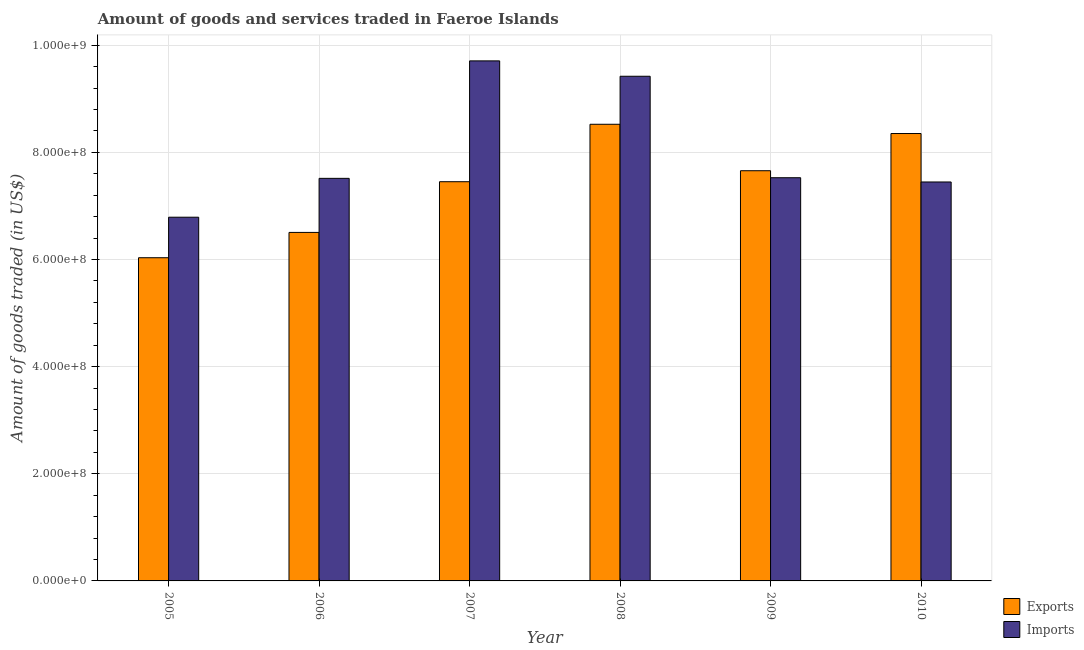How many groups of bars are there?
Your response must be concise. 6. Are the number of bars on each tick of the X-axis equal?
Provide a short and direct response. Yes. How many bars are there on the 2nd tick from the left?
Your answer should be very brief. 2. What is the label of the 1st group of bars from the left?
Ensure brevity in your answer.  2005. What is the amount of goods exported in 2007?
Ensure brevity in your answer.  7.45e+08. Across all years, what is the maximum amount of goods imported?
Provide a short and direct response. 9.71e+08. Across all years, what is the minimum amount of goods exported?
Offer a terse response. 6.03e+08. What is the total amount of goods exported in the graph?
Your answer should be very brief. 4.45e+09. What is the difference between the amount of goods exported in 2006 and that in 2010?
Make the answer very short. -1.85e+08. What is the difference between the amount of goods imported in 2006 and the amount of goods exported in 2008?
Make the answer very short. -1.91e+08. What is the average amount of goods imported per year?
Your response must be concise. 8.07e+08. What is the ratio of the amount of goods imported in 2005 to that in 2010?
Make the answer very short. 0.91. Is the amount of goods imported in 2005 less than that in 2006?
Provide a succinct answer. Yes. What is the difference between the highest and the second highest amount of goods imported?
Ensure brevity in your answer.  2.87e+07. What is the difference between the highest and the lowest amount of goods imported?
Your response must be concise. 2.92e+08. What does the 1st bar from the left in 2005 represents?
Your answer should be very brief. Exports. What does the 2nd bar from the right in 2010 represents?
Provide a succinct answer. Exports. What is the difference between two consecutive major ticks on the Y-axis?
Keep it short and to the point. 2.00e+08. Are the values on the major ticks of Y-axis written in scientific E-notation?
Offer a very short reply. Yes. Does the graph contain any zero values?
Provide a short and direct response. No. Does the graph contain grids?
Offer a very short reply. Yes. How many legend labels are there?
Your answer should be compact. 2. How are the legend labels stacked?
Ensure brevity in your answer.  Vertical. What is the title of the graph?
Provide a succinct answer. Amount of goods and services traded in Faeroe Islands. What is the label or title of the X-axis?
Provide a succinct answer. Year. What is the label or title of the Y-axis?
Your answer should be compact. Amount of goods traded (in US$). What is the Amount of goods traded (in US$) of Exports in 2005?
Your response must be concise. 6.03e+08. What is the Amount of goods traded (in US$) in Imports in 2005?
Give a very brief answer. 6.79e+08. What is the Amount of goods traded (in US$) of Exports in 2006?
Provide a succinct answer. 6.51e+08. What is the Amount of goods traded (in US$) of Imports in 2006?
Give a very brief answer. 7.51e+08. What is the Amount of goods traded (in US$) of Exports in 2007?
Offer a terse response. 7.45e+08. What is the Amount of goods traded (in US$) of Imports in 2007?
Ensure brevity in your answer.  9.71e+08. What is the Amount of goods traded (in US$) of Exports in 2008?
Offer a terse response. 8.52e+08. What is the Amount of goods traded (in US$) of Imports in 2008?
Keep it short and to the point. 9.42e+08. What is the Amount of goods traded (in US$) in Exports in 2009?
Ensure brevity in your answer.  7.66e+08. What is the Amount of goods traded (in US$) of Imports in 2009?
Your answer should be compact. 7.53e+08. What is the Amount of goods traded (in US$) in Exports in 2010?
Your answer should be very brief. 8.35e+08. What is the Amount of goods traded (in US$) in Imports in 2010?
Provide a succinct answer. 7.45e+08. Across all years, what is the maximum Amount of goods traded (in US$) in Exports?
Ensure brevity in your answer.  8.52e+08. Across all years, what is the maximum Amount of goods traded (in US$) of Imports?
Ensure brevity in your answer.  9.71e+08. Across all years, what is the minimum Amount of goods traded (in US$) in Exports?
Keep it short and to the point. 6.03e+08. Across all years, what is the minimum Amount of goods traded (in US$) in Imports?
Offer a very short reply. 6.79e+08. What is the total Amount of goods traded (in US$) in Exports in the graph?
Provide a short and direct response. 4.45e+09. What is the total Amount of goods traded (in US$) of Imports in the graph?
Provide a succinct answer. 4.84e+09. What is the difference between the Amount of goods traded (in US$) of Exports in 2005 and that in 2006?
Offer a very short reply. -4.73e+07. What is the difference between the Amount of goods traded (in US$) of Imports in 2005 and that in 2006?
Ensure brevity in your answer.  -7.25e+07. What is the difference between the Amount of goods traded (in US$) of Exports in 2005 and that in 2007?
Make the answer very short. -1.42e+08. What is the difference between the Amount of goods traded (in US$) of Imports in 2005 and that in 2007?
Your answer should be very brief. -2.92e+08. What is the difference between the Amount of goods traded (in US$) in Exports in 2005 and that in 2008?
Give a very brief answer. -2.49e+08. What is the difference between the Amount of goods traded (in US$) of Imports in 2005 and that in 2008?
Keep it short and to the point. -2.63e+08. What is the difference between the Amount of goods traded (in US$) in Exports in 2005 and that in 2009?
Provide a succinct answer. -1.62e+08. What is the difference between the Amount of goods traded (in US$) of Imports in 2005 and that in 2009?
Offer a terse response. -7.37e+07. What is the difference between the Amount of goods traded (in US$) of Exports in 2005 and that in 2010?
Your answer should be very brief. -2.32e+08. What is the difference between the Amount of goods traded (in US$) of Imports in 2005 and that in 2010?
Provide a short and direct response. -6.58e+07. What is the difference between the Amount of goods traded (in US$) of Exports in 2006 and that in 2007?
Offer a very short reply. -9.46e+07. What is the difference between the Amount of goods traded (in US$) of Imports in 2006 and that in 2007?
Offer a terse response. -2.19e+08. What is the difference between the Amount of goods traded (in US$) of Exports in 2006 and that in 2008?
Give a very brief answer. -2.02e+08. What is the difference between the Amount of goods traded (in US$) in Imports in 2006 and that in 2008?
Give a very brief answer. -1.91e+08. What is the difference between the Amount of goods traded (in US$) in Exports in 2006 and that in 2009?
Make the answer very short. -1.15e+08. What is the difference between the Amount of goods traded (in US$) of Imports in 2006 and that in 2009?
Offer a terse response. -1.19e+06. What is the difference between the Amount of goods traded (in US$) of Exports in 2006 and that in 2010?
Offer a terse response. -1.85e+08. What is the difference between the Amount of goods traded (in US$) in Imports in 2006 and that in 2010?
Your answer should be very brief. 6.74e+06. What is the difference between the Amount of goods traded (in US$) of Exports in 2007 and that in 2008?
Offer a terse response. -1.07e+08. What is the difference between the Amount of goods traded (in US$) in Imports in 2007 and that in 2008?
Offer a very short reply. 2.87e+07. What is the difference between the Amount of goods traded (in US$) of Exports in 2007 and that in 2009?
Your answer should be compact. -2.05e+07. What is the difference between the Amount of goods traded (in US$) in Imports in 2007 and that in 2009?
Your response must be concise. 2.18e+08. What is the difference between the Amount of goods traded (in US$) of Exports in 2007 and that in 2010?
Keep it short and to the point. -8.99e+07. What is the difference between the Amount of goods traded (in US$) in Imports in 2007 and that in 2010?
Offer a very short reply. 2.26e+08. What is the difference between the Amount of goods traded (in US$) in Exports in 2008 and that in 2009?
Keep it short and to the point. 8.67e+07. What is the difference between the Amount of goods traded (in US$) of Imports in 2008 and that in 2009?
Provide a succinct answer. 1.89e+08. What is the difference between the Amount of goods traded (in US$) in Exports in 2008 and that in 2010?
Your answer should be very brief. 1.73e+07. What is the difference between the Amount of goods traded (in US$) of Imports in 2008 and that in 2010?
Offer a very short reply. 1.97e+08. What is the difference between the Amount of goods traded (in US$) in Exports in 2009 and that in 2010?
Keep it short and to the point. -6.94e+07. What is the difference between the Amount of goods traded (in US$) in Imports in 2009 and that in 2010?
Offer a very short reply. 7.93e+06. What is the difference between the Amount of goods traded (in US$) of Exports in 2005 and the Amount of goods traded (in US$) of Imports in 2006?
Provide a succinct answer. -1.48e+08. What is the difference between the Amount of goods traded (in US$) of Exports in 2005 and the Amount of goods traded (in US$) of Imports in 2007?
Your response must be concise. -3.67e+08. What is the difference between the Amount of goods traded (in US$) in Exports in 2005 and the Amount of goods traded (in US$) in Imports in 2008?
Provide a short and direct response. -3.39e+08. What is the difference between the Amount of goods traded (in US$) of Exports in 2005 and the Amount of goods traded (in US$) of Imports in 2009?
Make the answer very short. -1.49e+08. What is the difference between the Amount of goods traded (in US$) in Exports in 2005 and the Amount of goods traded (in US$) in Imports in 2010?
Your answer should be very brief. -1.41e+08. What is the difference between the Amount of goods traded (in US$) in Exports in 2006 and the Amount of goods traded (in US$) in Imports in 2007?
Keep it short and to the point. -3.20e+08. What is the difference between the Amount of goods traded (in US$) of Exports in 2006 and the Amount of goods traded (in US$) of Imports in 2008?
Give a very brief answer. -2.91e+08. What is the difference between the Amount of goods traded (in US$) in Exports in 2006 and the Amount of goods traded (in US$) in Imports in 2009?
Your answer should be very brief. -1.02e+08. What is the difference between the Amount of goods traded (in US$) in Exports in 2006 and the Amount of goods traded (in US$) in Imports in 2010?
Make the answer very short. -9.41e+07. What is the difference between the Amount of goods traded (in US$) in Exports in 2007 and the Amount of goods traded (in US$) in Imports in 2008?
Ensure brevity in your answer.  -1.97e+08. What is the difference between the Amount of goods traded (in US$) of Exports in 2007 and the Amount of goods traded (in US$) of Imports in 2009?
Your response must be concise. -7.45e+06. What is the difference between the Amount of goods traded (in US$) in Exports in 2007 and the Amount of goods traded (in US$) in Imports in 2010?
Provide a short and direct response. 4.84e+05. What is the difference between the Amount of goods traded (in US$) in Exports in 2008 and the Amount of goods traded (in US$) in Imports in 2009?
Offer a very short reply. 9.98e+07. What is the difference between the Amount of goods traded (in US$) in Exports in 2008 and the Amount of goods traded (in US$) in Imports in 2010?
Offer a terse response. 1.08e+08. What is the difference between the Amount of goods traded (in US$) in Exports in 2009 and the Amount of goods traded (in US$) in Imports in 2010?
Provide a short and direct response. 2.10e+07. What is the average Amount of goods traded (in US$) in Exports per year?
Provide a succinct answer. 7.42e+08. What is the average Amount of goods traded (in US$) of Imports per year?
Your answer should be compact. 8.07e+08. In the year 2005, what is the difference between the Amount of goods traded (in US$) of Exports and Amount of goods traded (in US$) of Imports?
Give a very brief answer. -7.56e+07. In the year 2006, what is the difference between the Amount of goods traded (in US$) of Exports and Amount of goods traded (in US$) of Imports?
Your answer should be compact. -1.01e+08. In the year 2007, what is the difference between the Amount of goods traded (in US$) of Exports and Amount of goods traded (in US$) of Imports?
Keep it short and to the point. -2.26e+08. In the year 2008, what is the difference between the Amount of goods traded (in US$) of Exports and Amount of goods traded (in US$) of Imports?
Make the answer very short. -8.96e+07. In the year 2009, what is the difference between the Amount of goods traded (in US$) in Exports and Amount of goods traded (in US$) in Imports?
Offer a terse response. 1.31e+07. In the year 2010, what is the difference between the Amount of goods traded (in US$) of Exports and Amount of goods traded (in US$) of Imports?
Your response must be concise. 9.04e+07. What is the ratio of the Amount of goods traded (in US$) in Exports in 2005 to that in 2006?
Keep it short and to the point. 0.93. What is the ratio of the Amount of goods traded (in US$) of Imports in 2005 to that in 2006?
Provide a succinct answer. 0.9. What is the ratio of the Amount of goods traded (in US$) of Exports in 2005 to that in 2007?
Your answer should be compact. 0.81. What is the ratio of the Amount of goods traded (in US$) in Imports in 2005 to that in 2007?
Your answer should be compact. 0.7. What is the ratio of the Amount of goods traded (in US$) in Exports in 2005 to that in 2008?
Your answer should be very brief. 0.71. What is the ratio of the Amount of goods traded (in US$) of Imports in 2005 to that in 2008?
Offer a terse response. 0.72. What is the ratio of the Amount of goods traded (in US$) in Exports in 2005 to that in 2009?
Make the answer very short. 0.79. What is the ratio of the Amount of goods traded (in US$) of Imports in 2005 to that in 2009?
Make the answer very short. 0.9. What is the ratio of the Amount of goods traded (in US$) of Exports in 2005 to that in 2010?
Your answer should be compact. 0.72. What is the ratio of the Amount of goods traded (in US$) of Imports in 2005 to that in 2010?
Your answer should be very brief. 0.91. What is the ratio of the Amount of goods traded (in US$) in Exports in 2006 to that in 2007?
Your answer should be compact. 0.87. What is the ratio of the Amount of goods traded (in US$) of Imports in 2006 to that in 2007?
Provide a succinct answer. 0.77. What is the ratio of the Amount of goods traded (in US$) of Exports in 2006 to that in 2008?
Your response must be concise. 0.76. What is the ratio of the Amount of goods traded (in US$) in Imports in 2006 to that in 2008?
Provide a short and direct response. 0.8. What is the ratio of the Amount of goods traded (in US$) in Exports in 2006 to that in 2009?
Keep it short and to the point. 0.85. What is the ratio of the Amount of goods traded (in US$) in Imports in 2006 to that in 2009?
Offer a very short reply. 1. What is the ratio of the Amount of goods traded (in US$) of Exports in 2006 to that in 2010?
Ensure brevity in your answer.  0.78. What is the ratio of the Amount of goods traded (in US$) of Imports in 2006 to that in 2010?
Offer a very short reply. 1.01. What is the ratio of the Amount of goods traded (in US$) of Exports in 2007 to that in 2008?
Provide a short and direct response. 0.87. What is the ratio of the Amount of goods traded (in US$) in Imports in 2007 to that in 2008?
Your answer should be compact. 1.03. What is the ratio of the Amount of goods traded (in US$) of Exports in 2007 to that in 2009?
Keep it short and to the point. 0.97. What is the ratio of the Amount of goods traded (in US$) of Imports in 2007 to that in 2009?
Provide a succinct answer. 1.29. What is the ratio of the Amount of goods traded (in US$) in Exports in 2007 to that in 2010?
Keep it short and to the point. 0.89. What is the ratio of the Amount of goods traded (in US$) of Imports in 2007 to that in 2010?
Make the answer very short. 1.3. What is the ratio of the Amount of goods traded (in US$) in Exports in 2008 to that in 2009?
Offer a very short reply. 1.11. What is the ratio of the Amount of goods traded (in US$) of Imports in 2008 to that in 2009?
Keep it short and to the point. 1.25. What is the ratio of the Amount of goods traded (in US$) in Exports in 2008 to that in 2010?
Provide a succinct answer. 1.02. What is the ratio of the Amount of goods traded (in US$) in Imports in 2008 to that in 2010?
Keep it short and to the point. 1.26. What is the ratio of the Amount of goods traded (in US$) of Exports in 2009 to that in 2010?
Make the answer very short. 0.92. What is the ratio of the Amount of goods traded (in US$) in Imports in 2009 to that in 2010?
Offer a terse response. 1.01. What is the difference between the highest and the second highest Amount of goods traded (in US$) of Exports?
Your response must be concise. 1.73e+07. What is the difference between the highest and the second highest Amount of goods traded (in US$) in Imports?
Make the answer very short. 2.87e+07. What is the difference between the highest and the lowest Amount of goods traded (in US$) of Exports?
Make the answer very short. 2.49e+08. What is the difference between the highest and the lowest Amount of goods traded (in US$) in Imports?
Provide a succinct answer. 2.92e+08. 